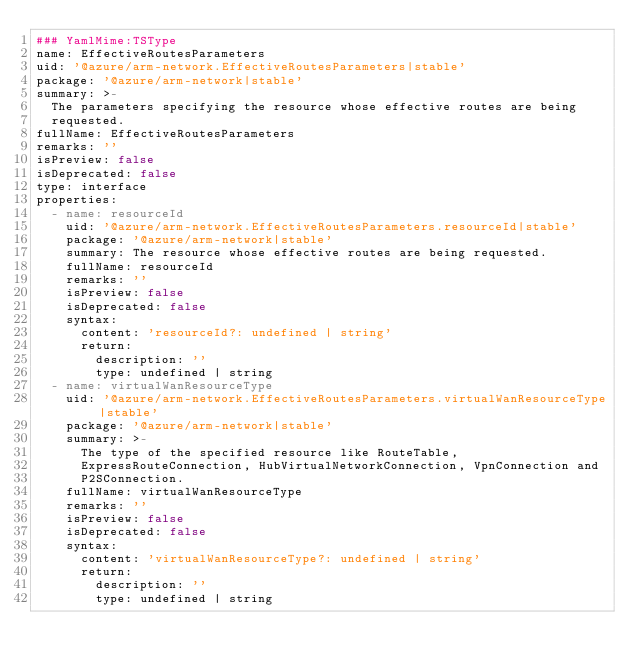Convert code to text. <code><loc_0><loc_0><loc_500><loc_500><_YAML_>### YamlMime:TSType
name: EffectiveRoutesParameters
uid: '@azure/arm-network.EffectiveRoutesParameters|stable'
package: '@azure/arm-network|stable'
summary: >-
  The parameters specifying the resource whose effective routes are being
  requested.
fullName: EffectiveRoutesParameters
remarks: ''
isPreview: false
isDeprecated: false
type: interface
properties:
  - name: resourceId
    uid: '@azure/arm-network.EffectiveRoutesParameters.resourceId|stable'
    package: '@azure/arm-network|stable'
    summary: The resource whose effective routes are being requested.
    fullName: resourceId
    remarks: ''
    isPreview: false
    isDeprecated: false
    syntax:
      content: 'resourceId?: undefined | string'
      return:
        description: ''
        type: undefined | string
  - name: virtualWanResourceType
    uid: '@azure/arm-network.EffectiveRoutesParameters.virtualWanResourceType|stable'
    package: '@azure/arm-network|stable'
    summary: >-
      The type of the specified resource like RouteTable,
      ExpressRouteConnection, HubVirtualNetworkConnection, VpnConnection and
      P2SConnection.
    fullName: virtualWanResourceType
    remarks: ''
    isPreview: false
    isDeprecated: false
    syntax:
      content: 'virtualWanResourceType?: undefined | string'
      return:
        description: ''
        type: undefined | string
</code> 